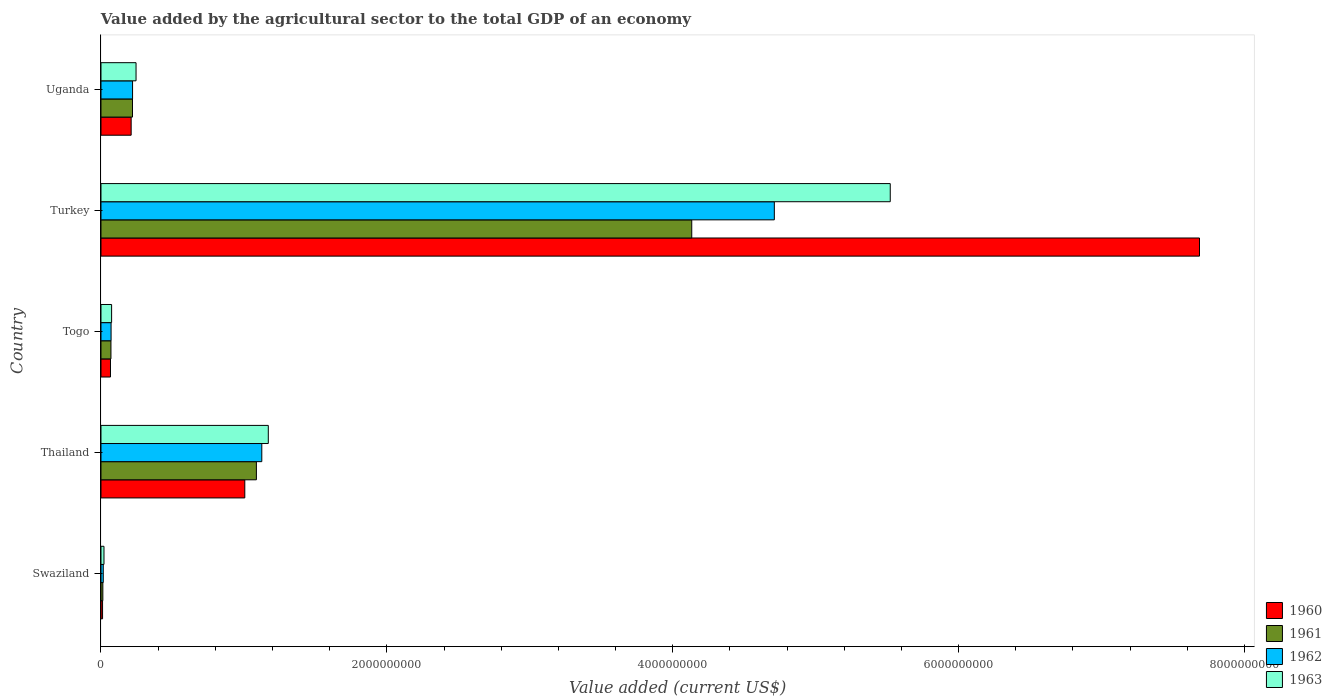How many bars are there on the 5th tick from the top?
Offer a terse response. 4. How many bars are there on the 2nd tick from the bottom?
Your response must be concise. 4. What is the label of the 3rd group of bars from the top?
Make the answer very short. Togo. In how many cases, is the number of bars for a given country not equal to the number of legend labels?
Keep it short and to the point. 0. What is the value added by the agricultural sector to the total GDP in 1960 in Uganda?
Your answer should be very brief. 2.11e+08. Across all countries, what is the maximum value added by the agricultural sector to the total GDP in 1963?
Your response must be concise. 5.52e+09. Across all countries, what is the minimum value added by the agricultural sector to the total GDP in 1963?
Give a very brief answer. 2.10e+07. In which country was the value added by the agricultural sector to the total GDP in 1960 minimum?
Your response must be concise. Swaziland. What is the total value added by the agricultural sector to the total GDP in 1963 in the graph?
Keep it short and to the point. 7.03e+09. What is the difference between the value added by the agricultural sector to the total GDP in 1960 in Swaziland and that in Togo?
Offer a very short reply. -5.54e+07. What is the difference between the value added by the agricultural sector to the total GDP in 1961 in Turkey and the value added by the agricultural sector to the total GDP in 1963 in Uganda?
Provide a short and direct response. 3.89e+09. What is the average value added by the agricultural sector to the total GDP in 1960 per country?
Your answer should be very brief. 1.80e+09. What is the difference between the value added by the agricultural sector to the total GDP in 1963 and value added by the agricultural sector to the total GDP in 1960 in Uganda?
Provide a short and direct response. 3.43e+07. What is the ratio of the value added by the agricultural sector to the total GDP in 1963 in Thailand to that in Turkey?
Keep it short and to the point. 0.21. What is the difference between the highest and the second highest value added by the agricultural sector to the total GDP in 1961?
Your response must be concise. 3.05e+09. What is the difference between the highest and the lowest value added by the agricultural sector to the total GDP in 1960?
Ensure brevity in your answer.  7.67e+09. In how many countries, is the value added by the agricultural sector to the total GDP in 1963 greater than the average value added by the agricultural sector to the total GDP in 1963 taken over all countries?
Offer a very short reply. 1. Is it the case that in every country, the sum of the value added by the agricultural sector to the total GDP in 1960 and value added by the agricultural sector to the total GDP in 1961 is greater than the sum of value added by the agricultural sector to the total GDP in 1962 and value added by the agricultural sector to the total GDP in 1963?
Provide a short and direct response. No. What does the 4th bar from the top in Togo represents?
Provide a short and direct response. 1960. Is it the case that in every country, the sum of the value added by the agricultural sector to the total GDP in 1961 and value added by the agricultural sector to the total GDP in 1963 is greater than the value added by the agricultural sector to the total GDP in 1962?
Offer a terse response. Yes. How many bars are there?
Give a very brief answer. 20. Are all the bars in the graph horizontal?
Offer a very short reply. Yes. What is the difference between two consecutive major ticks on the X-axis?
Keep it short and to the point. 2.00e+09. Are the values on the major ticks of X-axis written in scientific E-notation?
Ensure brevity in your answer.  No. Does the graph contain any zero values?
Provide a short and direct response. No. What is the title of the graph?
Make the answer very short. Value added by the agricultural sector to the total GDP of an economy. Does "1975" appear as one of the legend labels in the graph?
Ensure brevity in your answer.  No. What is the label or title of the X-axis?
Provide a succinct answer. Value added (current US$). What is the label or title of the Y-axis?
Give a very brief answer. Country. What is the Value added (current US$) in 1960 in Swaziland?
Offer a terse response. 1.11e+07. What is the Value added (current US$) in 1961 in Swaziland?
Keep it short and to the point. 1.30e+07. What is the Value added (current US$) in 1962 in Swaziland?
Your answer should be very brief. 1.60e+07. What is the Value added (current US$) of 1963 in Swaziland?
Make the answer very short. 2.10e+07. What is the Value added (current US$) of 1960 in Thailand?
Make the answer very short. 1.01e+09. What is the Value added (current US$) in 1961 in Thailand?
Your answer should be compact. 1.09e+09. What is the Value added (current US$) in 1962 in Thailand?
Offer a very short reply. 1.13e+09. What is the Value added (current US$) in 1963 in Thailand?
Provide a short and direct response. 1.17e+09. What is the Value added (current US$) of 1960 in Togo?
Offer a terse response. 6.65e+07. What is the Value added (current US$) of 1961 in Togo?
Provide a succinct answer. 6.97e+07. What is the Value added (current US$) of 1962 in Togo?
Give a very brief answer. 7.06e+07. What is the Value added (current US$) in 1963 in Togo?
Provide a succinct answer. 7.43e+07. What is the Value added (current US$) in 1960 in Turkey?
Your response must be concise. 7.69e+09. What is the Value added (current US$) of 1961 in Turkey?
Your answer should be compact. 4.13e+09. What is the Value added (current US$) in 1962 in Turkey?
Ensure brevity in your answer.  4.71e+09. What is the Value added (current US$) in 1963 in Turkey?
Offer a terse response. 5.52e+09. What is the Value added (current US$) in 1960 in Uganda?
Provide a short and direct response. 2.11e+08. What is the Value added (current US$) in 1961 in Uganda?
Offer a very short reply. 2.20e+08. What is the Value added (current US$) of 1962 in Uganda?
Provide a succinct answer. 2.21e+08. What is the Value added (current US$) of 1963 in Uganda?
Your answer should be very brief. 2.45e+08. Across all countries, what is the maximum Value added (current US$) in 1960?
Make the answer very short. 7.69e+09. Across all countries, what is the maximum Value added (current US$) in 1961?
Your response must be concise. 4.13e+09. Across all countries, what is the maximum Value added (current US$) of 1962?
Your answer should be compact. 4.71e+09. Across all countries, what is the maximum Value added (current US$) of 1963?
Provide a succinct answer. 5.52e+09. Across all countries, what is the minimum Value added (current US$) of 1960?
Ensure brevity in your answer.  1.11e+07. Across all countries, what is the minimum Value added (current US$) in 1961?
Make the answer very short. 1.30e+07. Across all countries, what is the minimum Value added (current US$) of 1962?
Make the answer very short. 1.60e+07. Across all countries, what is the minimum Value added (current US$) of 1963?
Make the answer very short. 2.10e+07. What is the total Value added (current US$) in 1960 in the graph?
Provide a short and direct response. 8.98e+09. What is the total Value added (current US$) of 1961 in the graph?
Offer a very short reply. 5.52e+09. What is the total Value added (current US$) in 1962 in the graph?
Provide a short and direct response. 6.14e+09. What is the total Value added (current US$) of 1963 in the graph?
Keep it short and to the point. 7.03e+09. What is the difference between the Value added (current US$) of 1960 in Swaziland and that in Thailand?
Offer a terse response. -9.95e+08. What is the difference between the Value added (current US$) of 1961 in Swaziland and that in Thailand?
Your answer should be very brief. -1.07e+09. What is the difference between the Value added (current US$) of 1962 in Swaziland and that in Thailand?
Give a very brief answer. -1.11e+09. What is the difference between the Value added (current US$) in 1963 in Swaziland and that in Thailand?
Offer a very short reply. -1.15e+09. What is the difference between the Value added (current US$) in 1960 in Swaziland and that in Togo?
Your answer should be very brief. -5.54e+07. What is the difference between the Value added (current US$) of 1961 in Swaziland and that in Togo?
Give a very brief answer. -5.67e+07. What is the difference between the Value added (current US$) of 1962 in Swaziland and that in Togo?
Offer a terse response. -5.46e+07. What is the difference between the Value added (current US$) in 1963 in Swaziland and that in Togo?
Ensure brevity in your answer.  -5.33e+07. What is the difference between the Value added (current US$) in 1960 in Swaziland and that in Turkey?
Ensure brevity in your answer.  -7.67e+09. What is the difference between the Value added (current US$) in 1961 in Swaziland and that in Turkey?
Your response must be concise. -4.12e+09. What is the difference between the Value added (current US$) in 1962 in Swaziland and that in Turkey?
Your response must be concise. -4.70e+09. What is the difference between the Value added (current US$) in 1963 in Swaziland and that in Turkey?
Offer a very short reply. -5.50e+09. What is the difference between the Value added (current US$) in 1960 in Swaziland and that in Uganda?
Offer a very short reply. -2.00e+08. What is the difference between the Value added (current US$) of 1961 in Swaziland and that in Uganda?
Give a very brief answer. -2.07e+08. What is the difference between the Value added (current US$) in 1962 in Swaziland and that in Uganda?
Ensure brevity in your answer.  -2.05e+08. What is the difference between the Value added (current US$) of 1963 in Swaziland and that in Uganda?
Ensure brevity in your answer.  -2.24e+08. What is the difference between the Value added (current US$) in 1960 in Thailand and that in Togo?
Ensure brevity in your answer.  9.40e+08. What is the difference between the Value added (current US$) in 1961 in Thailand and that in Togo?
Offer a very short reply. 1.02e+09. What is the difference between the Value added (current US$) in 1962 in Thailand and that in Togo?
Your answer should be compact. 1.05e+09. What is the difference between the Value added (current US$) of 1963 in Thailand and that in Togo?
Your answer should be compact. 1.10e+09. What is the difference between the Value added (current US$) in 1960 in Thailand and that in Turkey?
Give a very brief answer. -6.68e+09. What is the difference between the Value added (current US$) of 1961 in Thailand and that in Turkey?
Your answer should be very brief. -3.05e+09. What is the difference between the Value added (current US$) in 1962 in Thailand and that in Turkey?
Give a very brief answer. -3.59e+09. What is the difference between the Value added (current US$) in 1963 in Thailand and that in Turkey?
Provide a succinct answer. -4.35e+09. What is the difference between the Value added (current US$) in 1960 in Thailand and that in Uganda?
Keep it short and to the point. 7.95e+08. What is the difference between the Value added (current US$) of 1961 in Thailand and that in Uganda?
Offer a very short reply. 8.67e+08. What is the difference between the Value added (current US$) of 1962 in Thailand and that in Uganda?
Your answer should be very brief. 9.04e+08. What is the difference between the Value added (current US$) in 1963 in Thailand and that in Uganda?
Your response must be concise. 9.25e+08. What is the difference between the Value added (current US$) of 1960 in Togo and that in Turkey?
Your answer should be very brief. -7.62e+09. What is the difference between the Value added (current US$) of 1961 in Togo and that in Turkey?
Your answer should be very brief. -4.06e+09. What is the difference between the Value added (current US$) in 1962 in Togo and that in Turkey?
Your answer should be compact. -4.64e+09. What is the difference between the Value added (current US$) in 1963 in Togo and that in Turkey?
Your answer should be very brief. -5.45e+09. What is the difference between the Value added (current US$) of 1960 in Togo and that in Uganda?
Offer a very short reply. -1.45e+08. What is the difference between the Value added (current US$) of 1961 in Togo and that in Uganda?
Your response must be concise. -1.51e+08. What is the difference between the Value added (current US$) of 1962 in Togo and that in Uganda?
Offer a terse response. -1.50e+08. What is the difference between the Value added (current US$) in 1963 in Togo and that in Uganda?
Offer a very short reply. -1.71e+08. What is the difference between the Value added (current US$) in 1960 in Turkey and that in Uganda?
Your answer should be very brief. 7.47e+09. What is the difference between the Value added (current US$) of 1961 in Turkey and that in Uganda?
Make the answer very short. 3.91e+09. What is the difference between the Value added (current US$) in 1962 in Turkey and that in Uganda?
Provide a succinct answer. 4.49e+09. What is the difference between the Value added (current US$) in 1963 in Turkey and that in Uganda?
Offer a very short reply. 5.28e+09. What is the difference between the Value added (current US$) of 1960 in Swaziland and the Value added (current US$) of 1961 in Thailand?
Offer a very short reply. -1.08e+09. What is the difference between the Value added (current US$) of 1960 in Swaziland and the Value added (current US$) of 1962 in Thailand?
Give a very brief answer. -1.11e+09. What is the difference between the Value added (current US$) of 1960 in Swaziland and the Value added (current US$) of 1963 in Thailand?
Your response must be concise. -1.16e+09. What is the difference between the Value added (current US$) of 1961 in Swaziland and the Value added (current US$) of 1962 in Thailand?
Provide a short and direct response. -1.11e+09. What is the difference between the Value added (current US$) of 1961 in Swaziland and the Value added (current US$) of 1963 in Thailand?
Ensure brevity in your answer.  -1.16e+09. What is the difference between the Value added (current US$) in 1962 in Swaziland and the Value added (current US$) in 1963 in Thailand?
Your response must be concise. -1.15e+09. What is the difference between the Value added (current US$) in 1960 in Swaziland and the Value added (current US$) in 1961 in Togo?
Offer a terse response. -5.87e+07. What is the difference between the Value added (current US$) in 1960 in Swaziland and the Value added (current US$) in 1962 in Togo?
Make the answer very short. -5.95e+07. What is the difference between the Value added (current US$) in 1960 in Swaziland and the Value added (current US$) in 1963 in Togo?
Ensure brevity in your answer.  -6.32e+07. What is the difference between the Value added (current US$) in 1961 in Swaziland and the Value added (current US$) in 1962 in Togo?
Offer a terse response. -5.76e+07. What is the difference between the Value added (current US$) in 1961 in Swaziland and the Value added (current US$) in 1963 in Togo?
Ensure brevity in your answer.  -6.13e+07. What is the difference between the Value added (current US$) of 1962 in Swaziland and the Value added (current US$) of 1963 in Togo?
Give a very brief answer. -5.83e+07. What is the difference between the Value added (current US$) of 1960 in Swaziland and the Value added (current US$) of 1961 in Turkey?
Ensure brevity in your answer.  -4.12e+09. What is the difference between the Value added (current US$) in 1960 in Swaziland and the Value added (current US$) in 1962 in Turkey?
Offer a very short reply. -4.70e+09. What is the difference between the Value added (current US$) in 1960 in Swaziland and the Value added (current US$) in 1963 in Turkey?
Your answer should be compact. -5.51e+09. What is the difference between the Value added (current US$) of 1961 in Swaziland and the Value added (current US$) of 1962 in Turkey?
Your answer should be compact. -4.70e+09. What is the difference between the Value added (current US$) in 1961 in Swaziland and the Value added (current US$) in 1963 in Turkey?
Offer a very short reply. -5.51e+09. What is the difference between the Value added (current US$) of 1962 in Swaziland and the Value added (current US$) of 1963 in Turkey?
Offer a terse response. -5.51e+09. What is the difference between the Value added (current US$) of 1960 in Swaziland and the Value added (current US$) of 1961 in Uganda?
Your response must be concise. -2.09e+08. What is the difference between the Value added (current US$) of 1960 in Swaziland and the Value added (current US$) of 1962 in Uganda?
Make the answer very short. -2.10e+08. What is the difference between the Value added (current US$) in 1960 in Swaziland and the Value added (current US$) in 1963 in Uganda?
Your answer should be compact. -2.34e+08. What is the difference between the Value added (current US$) of 1961 in Swaziland and the Value added (current US$) of 1962 in Uganda?
Your response must be concise. -2.08e+08. What is the difference between the Value added (current US$) in 1961 in Swaziland and the Value added (current US$) in 1963 in Uganda?
Give a very brief answer. -2.32e+08. What is the difference between the Value added (current US$) of 1962 in Swaziland and the Value added (current US$) of 1963 in Uganda?
Make the answer very short. -2.29e+08. What is the difference between the Value added (current US$) of 1960 in Thailand and the Value added (current US$) of 1961 in Togo?
Offer a terse response. 9.36e+08. What is the difference between the Value added (current US$) of 1960 in Thailand and the Value added (current US$) of 1962 in Togo?
Ensure brevity in your answer.  9.36e+08. What is the difference between the Value added (current US$) in 1960 in Thailand and the Value added (current US$) in 1963 in Togo?
Give a very brief answer. 9.32e+08. What is the difference between the Value added (current US$) of 1961 in Thailand and the Value added (current US$) of 1962 in Togo?
Give a very brief answer. 1.02e+09. What is the difference between the Value added (current US$) in 1961 in Thailand and the Value added (current US$) in 1963 in Togo?
Make the answer very short. 1.01e+09. What is the difference between the Value added (current US$) in 1962 in Thailand and the Value added (current US$) in 1963 in Togo?
Offer a terse response. 1.05e+09. What is the difference between the Value added (current US$) in 1960 in Thailand and the Value added (current US$) in 1961 in Turkey?
Ensure brevity in your answer.  -3.13e+09. What is the difference between the Value added (current US$) of 1960 in Thailand and the Value added (current US$) of 1962 in Turkey?
Provide a short and direct response. -3.70e+09. What is the difference between the Value added (current US$) in 1960 in Thailand and the Value added (current US$) in 1963 in Turkey?
Ensure brevity in your answer.  -4.52e+09. What is the difference between the Value added (current US$) in 1961 in Thailand and the Value added (current US$) in 1962 in Turkey?
Your response must be concise. -3.62e+09. What is the difference between the Value added (current US$) in 1961 in Thailand and the Value added (current US$) in 1963 in Turkey?
Your answer should be compact. -4.43e+09. What is the difference between the Value added (current US$) of 1962 in Thailand and the Value added (current US$) of 1963 in Turkey?
Make the answer very short. -4.40e+09. What is the difference between the Value added (current US$) in 1960 in Thailand and the Value added (current US$) in 1961 in Uganda?
Give a very brief answer. 7.86e+08. What is the difference between the Value added (current US$) in 1960 in Thailand and the Value added (current US$) in 1962 in Uganda?
Offer a terse response. 7.85e+08. What is the difference between the Value added (current US$) of 1960 in Thailand and the Value added (current US$) of 1963 in Uganda?
Keep it short and to the point. 7.61e+08. What is the difference between the Value added (current US$) of 1961 in Thailand and the Value added (current US$) of 1962 in Uganda?
Offer a very short reply. 8.66e+08. What is the difference between the Value added (current US$) of 1961 in Thailand and the Value added (current US$) of 1963 in Uganda?
Provide a succinct answer. 8.42e+08. What is the difference between the Value added (current US$) of 1962 in Thailand and the Value added (current US$) of 1963 in Uganda?
Keep it short and to the point. 8.80e+08. What is the difference between the Value added (current US$) of 1960 in Togo and the Value added (current US$) of 1961 in Turkey?
Your response must be concise. -4.07e+09. What is the difference between the Value added (current US$) of 1960 in Togo and the Value added (current US$) of 1962 in Turkey?
Your answer should be compact. -4.64e+09. What is the difference between the Value added (current US$) of 1960 in Togo and the Value added (current US$) of 1963 in Turkey?
Your response must be concise. -5.46e+09. What is the difference between the Value added (current US$) in 1961 in Togo and the Value added (current US$) in 1962 in Turkey?
Offer a very short reply. -4.64e+09. What is the difference between the Value added (current US$) in 1961 in Togo and the Value added (current US$) in 1963 in Turkey?
Your response must be concise. -5.45e+09. What is the difference between the Value added (current US$) in 1962 in Togo and the Value added (current US$) in 1963 in Turkey?
Ensure brevity in your answer.  -5.45e+09. What is the difference between the Value added (current US$) in 1960 in Togo and the Value added (current US$) in 1961 in Uganda?
Give a very brief answer. -1.54e+08. What is the difference between the Value added (current US$) in 1960 in Togo and the Value added (current US$) in 1962 in Uganda?
Your answer should be very brief. -1.54e+08. What is the difference between the Value added (current US$) of 1960 in Togo and the Value added (current US$) of 1963 in Uganda?
Provide a short and direct response. -1.79e+08. What is the difference between the Value added (current US$) in 1961 in Togo and the Value added (current US$) in 1962 in Uganda?
Your answer should be compact. -1.51e+08. What is the difference between the Value added (current US$) of 1961 in Togo and the Value added (current US$) of 1963 in Uganda?
Your answer should be compact. -1.76e+08. What is the difference between the Value added (current US$) in 1962 in Togo and the Value added (current US$) in 1963 in Uganda?
Give a very brief answer. -1.75e+08. What is the difference between the Value added (current US$) of 1960 in Turkey and the Value added (current US$) of 1961 in Uganda?
Offer a terse response. 7.47e+09. What is the difference between the Value added (current US$) of 1960 in Turkey and the Value added (current US$) of 1962 in Uganda?
Ensure brevity in your answer.  7.47e+09. What is the difference between the Value added (current US$) of 1960 in Turkey and the Value added (current US$) of 1963 in Uganda?
Provide a short and direct response. 7.44e+09. What is the difference between the Value added (current US$) in 1961 in Turkey and the Value added (current US$) in 1962 in Uganda?
Ensure brevity in your answer.  3.91e+09. What is the difference between the Value added (current US$) in 1961 in Turkey and the Value added (current US$) in 1963 in Uganda?
Provide a short and direct response. 3.89e+09. What is the difference between the Value added (current US$) of 1962 in Turkey and the Value added (current US$) of 1963 in Uganda?
Provide a short and direct response. 4.47e+09. What is the average Value added (current US$) of 1960 per country?
Make the answer very short. 1.80e+09. What is the average Value added (current US$) of 1961 per country?
Ensure brevity in your answer.  1.10e+09. What is the average Value added (current US$) in 1962 per country?
Give a very brief answer. 1.23e+09. What is the average Value added (current US$) in 1963 per country?
Your answer should be very brief. 1.41e+09. What is the difference between the Value added (current US$) in 1960 and Value added (current US$) in 1961 in Swaziland?
Provide a short and direct response. -1.96e+06. What is the difference between the Value added (current US$) in 1960 and Value added (current US$) in 1962 in Swaziland?
Keep it short and to the point. -4.90e+06. What is the difference between the Value added (current US$) of 1960 and Value added (current US$) of 1963 in Swaziland?
Offer a very short reply. -9.94e+06. What is the difference between the Value added (current US$) of 1961 and Value added (current US$) of 1962 in Swaziland?
Your response must be concise. -2.94e+06. What is the difference between the Value added (current US$) of 1961 and Value added (current US$) of 1963 in Swaziland?
Give a very brief answer. -7.98e+06. What is the difference between the Value added (current US$) in 1962 and Value added (current US$) in 1963 in Swaziland?
Make the answer very short. -5.04e+06. What is the difference between the Value added (current US$) in 1960 and Value added (current US$) in 1961 in Thailand?
Offer a very short reply. -8.12e+07. What is the difference between the Value added (current US$) in 1960 and Value added (current US$) in 1962 in Thailand?
Your response must be concise. -1.19e+08. What is the difference between the Value added (current US$) of 1960 and Value added (current US$) of 1963 in Thailand?
Keep it short and to the point. -1.65e+08. What is the difference between the Value added (current US$) in 1961 and Value added (current US$) in 1962 in Thailand?
Give a very brief answer. -3.78e+07. What is the difference between the Value added (current US$) in 1961 and Value added (current US$) in 1963 in Thailand?
Give a very brief answer. -8.33e+07. What is the difference between the Value added (current US$) in 1962 and Value added (current US$) in 1963 in Thailand?
Keep it short and to the point. -4.55e+07. What is the difference between the Value added (current US$) of 1960 and Value added (current US$) of 1961 in Togo?
Provide a succinct answer. -3.24e+06. What is the difference between the Value added (current US$) of 1960 and Value added (current US$) of 1962 in Togo?
Offer a terse response. -4.13e+06. What is the difference between the Value added (current US$) of 1960 and Value added (current US$) of 1963 in Togo?
Offer a very short reply. -7.80e+06. What is the difference between the Value added (current US$) of 1961 and Value added (current US$) of 1962 in Togo?
Provide a succinct answer. -8.86e+05. What is the difference between the Value added (current US$) of 1961 and Value added (current US$) of 1963 in Togo?
Give a very brief answer. -4.56e+06. What is the difference between the Value added (current US$) in 1962 and Value added (current US$) in 1963 in Togo?
Offer a very short reply. -3.67e+06. What is the difference between the Value added (current US$) in 1960 and Value added (current US$) in 1961 in Turkey?
Offer a terse response. 3.55e+09. What is the difference between the Value added (current US$) in 1960 and Value added (current US$) in 1962 in Turkey?
Make the answer very short. 2.97e+09. What is the difference between the Value added (current US$) of 1960 and Value added (current US$) of 1963 in Turkey?
Provide a succinct answer. 2.16e+09. What is the difference between the Value added (current US$) in 1961 and Value added (current US$) in 1962 in Turkey?
Make the answer very short. -5.78e+08. What is the difference between the Value added (current US$) in 1961 and Value added (current US$) in 1963 in Turkey?
Give a very brief answer. -1.39e+09. What is the difference between the Value added (current US$) of 1962 and Value added (current US$) of 1963 in Turkey?
Keep it short and to the point. -8.11e+08. What is the difference between the Value added (current US$) in 1960 and Value added (current US$) in 1961 in Uganda?
Make the answer very short. -9.45e+06. What is the difference between the Value added (current US$) in 1960 and Value added (current US$) in 1962 in Uganda?
Offer a terse response. -9.86e+06. What is the difference between the Value added (current US$) of 1960 and Value added (current US$) of 1963 in Uganda?
Give a very brief answer. -3.43e+07. What is the difference between the Value added (current US$) in 1961 and Value added (current US$) in 1962 in Uganda?
Give a very brief answer. -4.07e+05. What is the difference between the Value added (current US$) of 1961 and Value added (current US$) of 1963 in Uganda?
Give a very brief answer. -2.48e+07. What is the difference between the Value added (current US$) of 1962 and Value added (current US$) of 1963 in Uganda?
Your answer should be very brief. -2.44e+07. What is the ratio of the Value added (current US$) of 1960 in Swaziland to that in Thailand?
Give a very brief answer. 0.01. What is the ratio of the Value added (current US$) of 1961 in Swaziland to that in Thailand?
Make the answer very short. 0.01. What is the ratio of the Value added (current US$) of 1962 in Swaziland to that in Thailand?
Offer a very short reply. 0.01. What is the ratio of the Value added (current US$) in 1963 in Swaziland to that in Thailand?
Provide a succinct answer. 0.02. What is the ratio of the Value added (current US$) of 1960 in Swaziland to that in Togo?
Offer a terse response. 0.17. What is the ratio of the Value added (current US$) of 1961 in Swaziland to that in Togo?
Offer a terse response. 0.19. What is the ratio of the Value added (current US$) of 1962 in Swaziland to that in Togo?
Your answer should be compact. 0.23. What is the ratio of the Value added (current US$) in 1963 in Swaziland to that in Togo?
Make the answer very short. 0.28. What is the ratio of the Value added (current US$) in 1960 in Swaziland to that in Turkey?
Provide a short and direct response. 0. What is the ratio of the Value added (current US$) in 1961 in Swaziland to that in Turkey?
Provide a short and direct response. 0. What is the ratio of the Value added (current US$) of 1962 in Swaziland to that in Turkey?
Make the answer very short. 0. What is the ratio of the Value added (current US$) in 1963 in Swaziland to that in Turkey?
Give a very brief answer. 0. What is the ratio of the Value added (current US$) of 1960 in Swaziland to that in Uganda?
Ensure brevity in your answer.  0.05. What is the ratio of the Value added (current US$) of 1961 in Swaziland to that in Uganda?
Your response must be concise. 0.06. What is the ratio of the Value added (current US$) of 1962 in Swaziland to that in Uganda?
Ensure brevity in your answer.  0.07. What is the ratio of the Value added (current US$) of 1963 in Swaziland to that in Uganda?
Offer a very short reply. 0.09. What is the ratio of the Value added (current US$) in 1960 in Thailand to that in Togo?
Your answer should be very brief. 15.13. What is the ratio of the Value added (current US$) in 1961 in Thailand to that in Togo?
Provide a short and direct response. 15.6. What is the ratio of the Value added (current US$) in 1962 in Thailand to that in Togo?
Provide a succinct answer. 15.93. What is the ratio of the Value added (current US$) in 1963 in Thailand to that in Togo?
Offer a very short reply. 15.76. What is the ratio of the Value added (current US$) in 1960 in Thailand to that in Turkey?
Offer a terse response. 0.13. What is the ratio of the Value added (current US$) of 1961 in Thailand to that in Turkey?
Offer a very short reply. 0.26. What is the ratio of the Value added (current US$) of 1962 in Thailand to that in Turkey?
Make the answer very short. 0.24. What is the ratio of the Value added (current US$) in 1963 in Thailand to that in Turkey?
Offer a terse response. 0.21. What is the ratio of the Value added (current US$) of 1960 in Thailand to that in Uganda?
Make the answer very short. 4.77. What is the ratio of the Value added (current US$) of 1961 in Thailand to that in Uganda?
Your answer should be very brief. 4.93. What is the ratio of the Value added (current US$) of 1962 in Thailand to that in Uganda?
Keep it short and to the point. 5.09. What is the ratio of the Value added (current US$) in 1963 in Thailand to that in Uganda?
Provide a succinct answer. 4.77. What is the ratio of the Value added (current US$) in 1960 in Togo to that in Turkey?
Make the answer very short. 0.01. What is the ratio of the Value added (current US$) in 1961 in Togo to that in Turkey?
Ensure brevity in your answer.  0.02. What is the ratio of the Value added (current US$) of 1962 in Togo to that in Turkey?
Ensure brevity in your answer.  0.01. What is the ratio of the Value added (current US$) in 1963 in Togo to that in Turkey?
Give a very brief answer. 0.01. What is the ratio of the Value added (current US$) of 1960 in Togo to that in Uganda?
Ensure brevity in your answer.  0.32. What is the ratio of the Value added (current US$) of 1961 in Togo to that in Uganda?
Provide a short and direct response. 0.32. What is the ratio of the Value added (current US$) in 1962 in Togo to that in Uganda?
Give a very brief answer. 0.32. What is the ratio of the Value added (current US$) in 1963 in Togo to that in Uganda?
Provide a short and direct response. 0.3. What is the ratio of the Value added (current US$) of 1960 in Turkey to that in Uganda?
Ensure brevity in your answer.  36.42. What is the ratio of the Value added (current US$) in 1961 in Turkey to that in Uganda?
Ensure brevity in your answer.  18.75. What is the ratio of the Value added (current US$) in 1962 in Turkey to that in Uganda?
Your answer should be very brief. 21.33. What is the ratio of the Value added (current US$) of 1963 in Turkey to that in Uganda?
Make the answer very short. 22.51. What is the difference between the highest and the second highest Value added (current US$) of 1960?
Offer a very short reply. 6.68e+09. What is the difference between the highest and the second highest Value added (current US$) of 1961?
Ensure brevity in your answer.  3.05e+09. What is the difference between the highest and the second highest Value added (current US$) in 1962?
Make the answer very short. 3.59e+09. What is the difference between the highest and the second highest Value added (current US$) in 1963?
Make the answer very short. 4.35e+09. What is the difference between the highest and the lowest Value added (current US$) in 1960?
Offer a very short reply. 7.67e+09. What is the difference between the highest and the lowest Value added (current US$) in 1961?
Make the answer very short. 4.12e+09. What is the difference between the highest and the lowest Value added (current US$) of 1962?
Make the answer very short. 4.70e+09. What is the difference between the highest and the lowest Value added (current US$) of 1963?
Provide a succinct answer. 5.50e+09. 